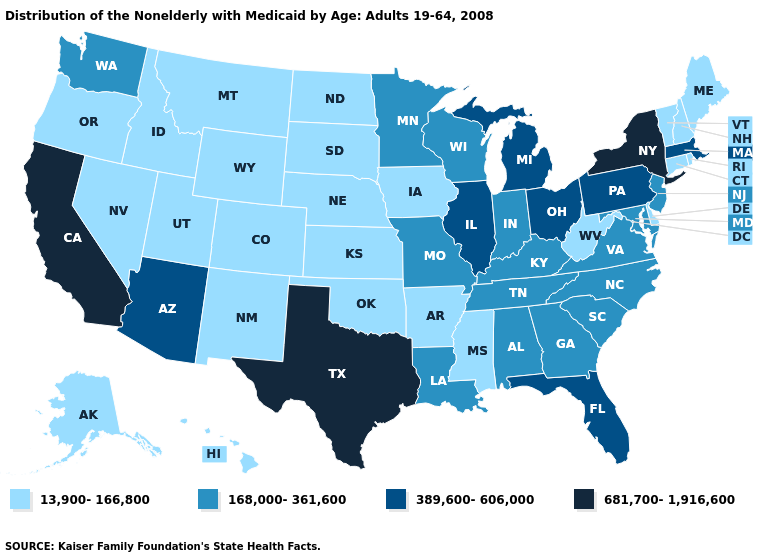Among the states that border Alabama , which have the lowest value?
Keep it brief. Mississippi. Does Delaware have the highest value in the South?
Give a very brief answer. No. What is the value of Colorado?
Answer briefly. 13,900-166,800. Does Florida have the lowest value in the USA?
Keep it brief. No. Name the states that have a value in the range 168,000-361,600?
Short answer required. Alabama, Georgia, Indiana, Kentucky, Louisiana, Maryland, Minnesota, Missouri, New Jersey, North Carolina, South Carolina, Tennessee, Virginia, Washington, Wisconsin. What is the highest value in the USA?
Be succinct. 681,700-1,916,600. What is the lowest value in the USA?
Write a very short answer. 13,900-166,800. Which states have the highest value in the USA?
Short answer required. California, New York, Texas. Among the states that border Arizona , which have the highest value?
Keep it brief. California. What is the lowest value in states that border Oregon?
Answer briefly. 13,900-166,800. What is the highest value in the West ?
Write a very short answer. 681,700-1,916,600. What is the value of South Dakota?
Be succinct. 13,900-166,800. What is the highest value in the South ?
Answer briefly. 681,700-1,916,600. How many symbols are there in the legend?
Keep it brief. 4. Does the first symbol in the legend represent the smallest category?
Quick response, please. Yes. 